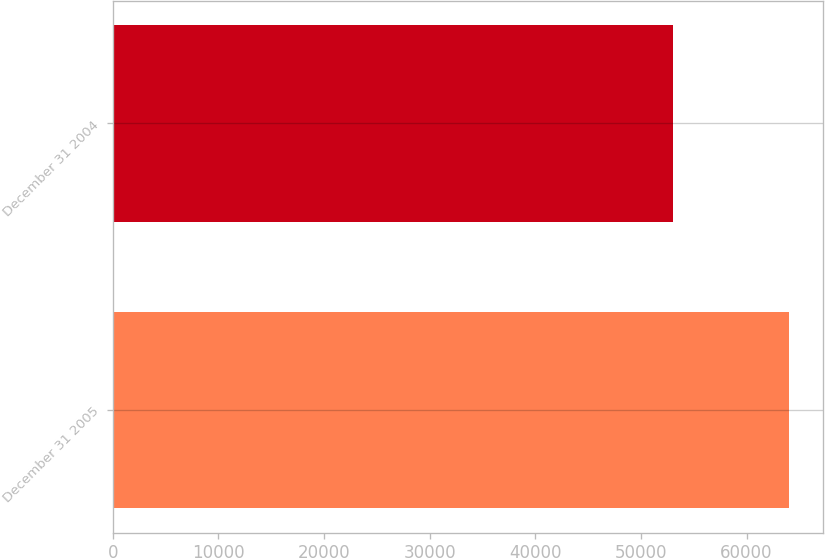Convert chart to OTSL. <chart><loc_0><loc_0><loc_500><loc_500><bar_chart><fcel>December 31 2005<fcel>December 31 2004<nl><fcel>64050<fcel>53083<nl></chart> 